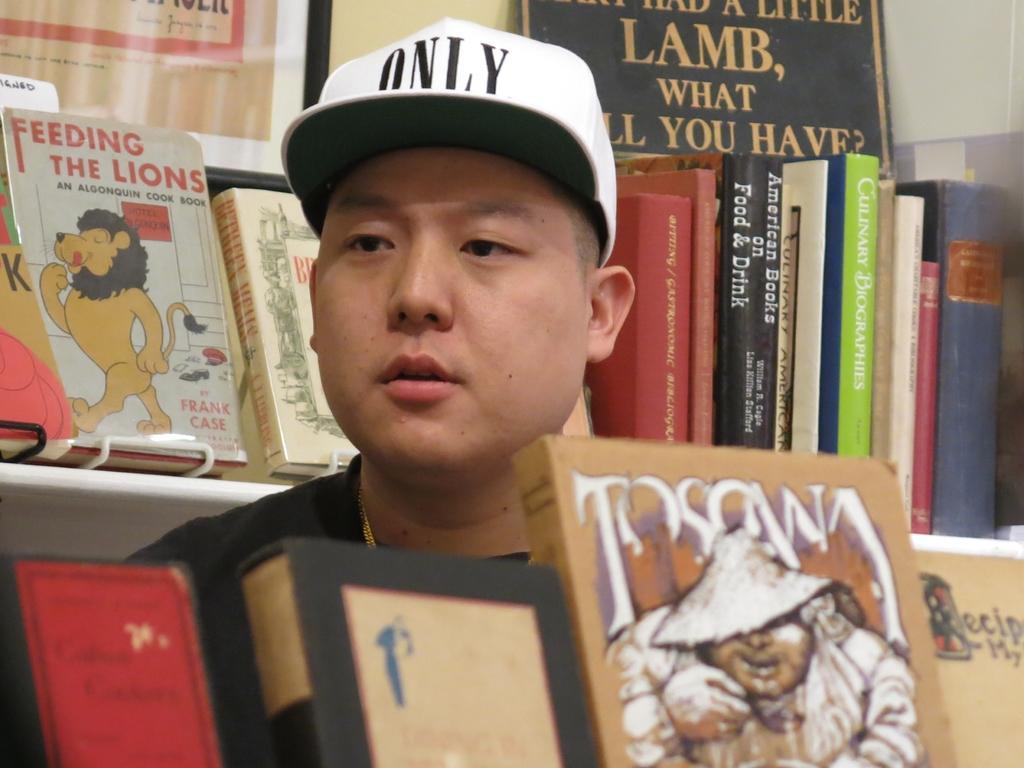How would you summarize this image in a sentence or two? At the bottom of the image there are books. Behind the books there is a man with a cap on his head. Behind him there is a rack with books. At the top of the image on the wall there are frames with text on it. 